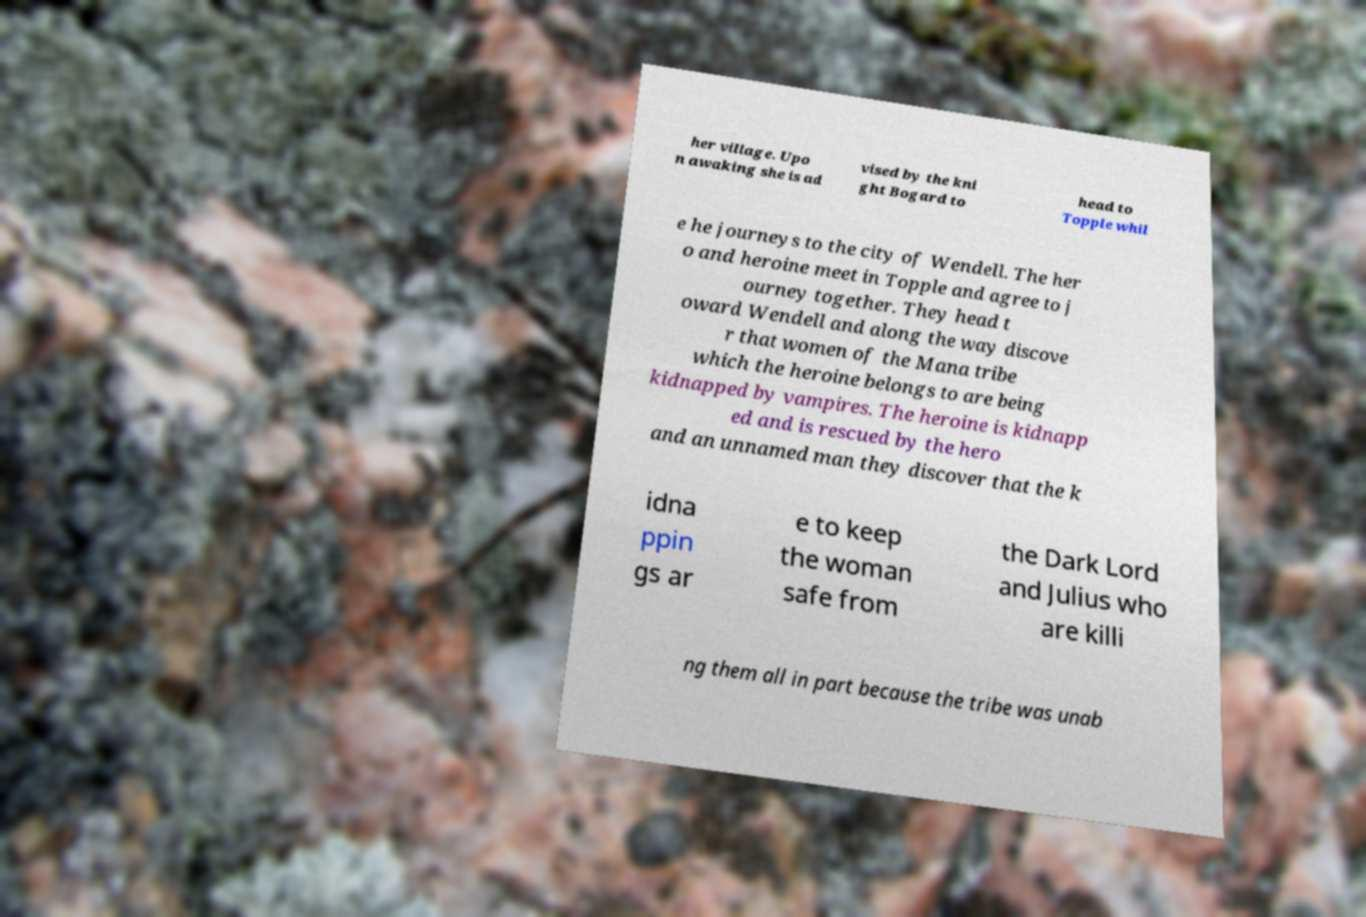Please identify and transcribe the text found in this image. her village. Upo n awaking she is ad vised by the kni ght Bogard to head to Topple whil e he journeys to the city of Wendell. The her o and heroine meet in Topple and agree to j ourney together. They head t oward Wendell and along the way discove r that women of the Mana tribe which the heroine belongs to are being kidnapped by vampires. The heroine is kidnapp ed and is rescued by the hero and an unnamed man they discover that the k idna ppin gs ar e to keep the woman safe from the Dark Lord and Julius who are killi ng them all in part because the tribe was unab 